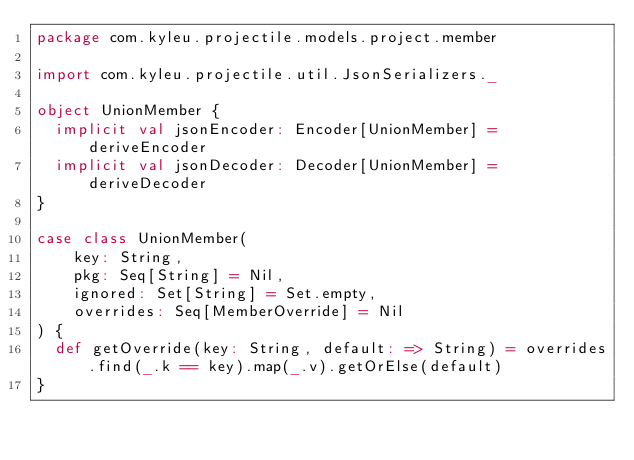Convert code to text. <code><loc_0><loc_0><loc_500><loc_500><_Scala_>package com.kyleu.projectile.models.project.member

import com.kyleu.projectile.util.JsonSerializers._

object UnionMember {
  implicit val jsonEncoder: Encoder[UnionMember] = deriveEncoder
  implicit val jsonDecoder: Decoder[UnionMember] = deriveDecoder
}

case class UnionMember(
    key: String,
    pkg: Seq[String] = Nil,
    ignored: Set[String] = Set.empty,
    overrides: Seq[MemberOverride] = Nil
) {
  def getOverride(key: String, default: => String) = overrides.find(_.k == key).map(_.v).getOrElse(default)
}
</code> 